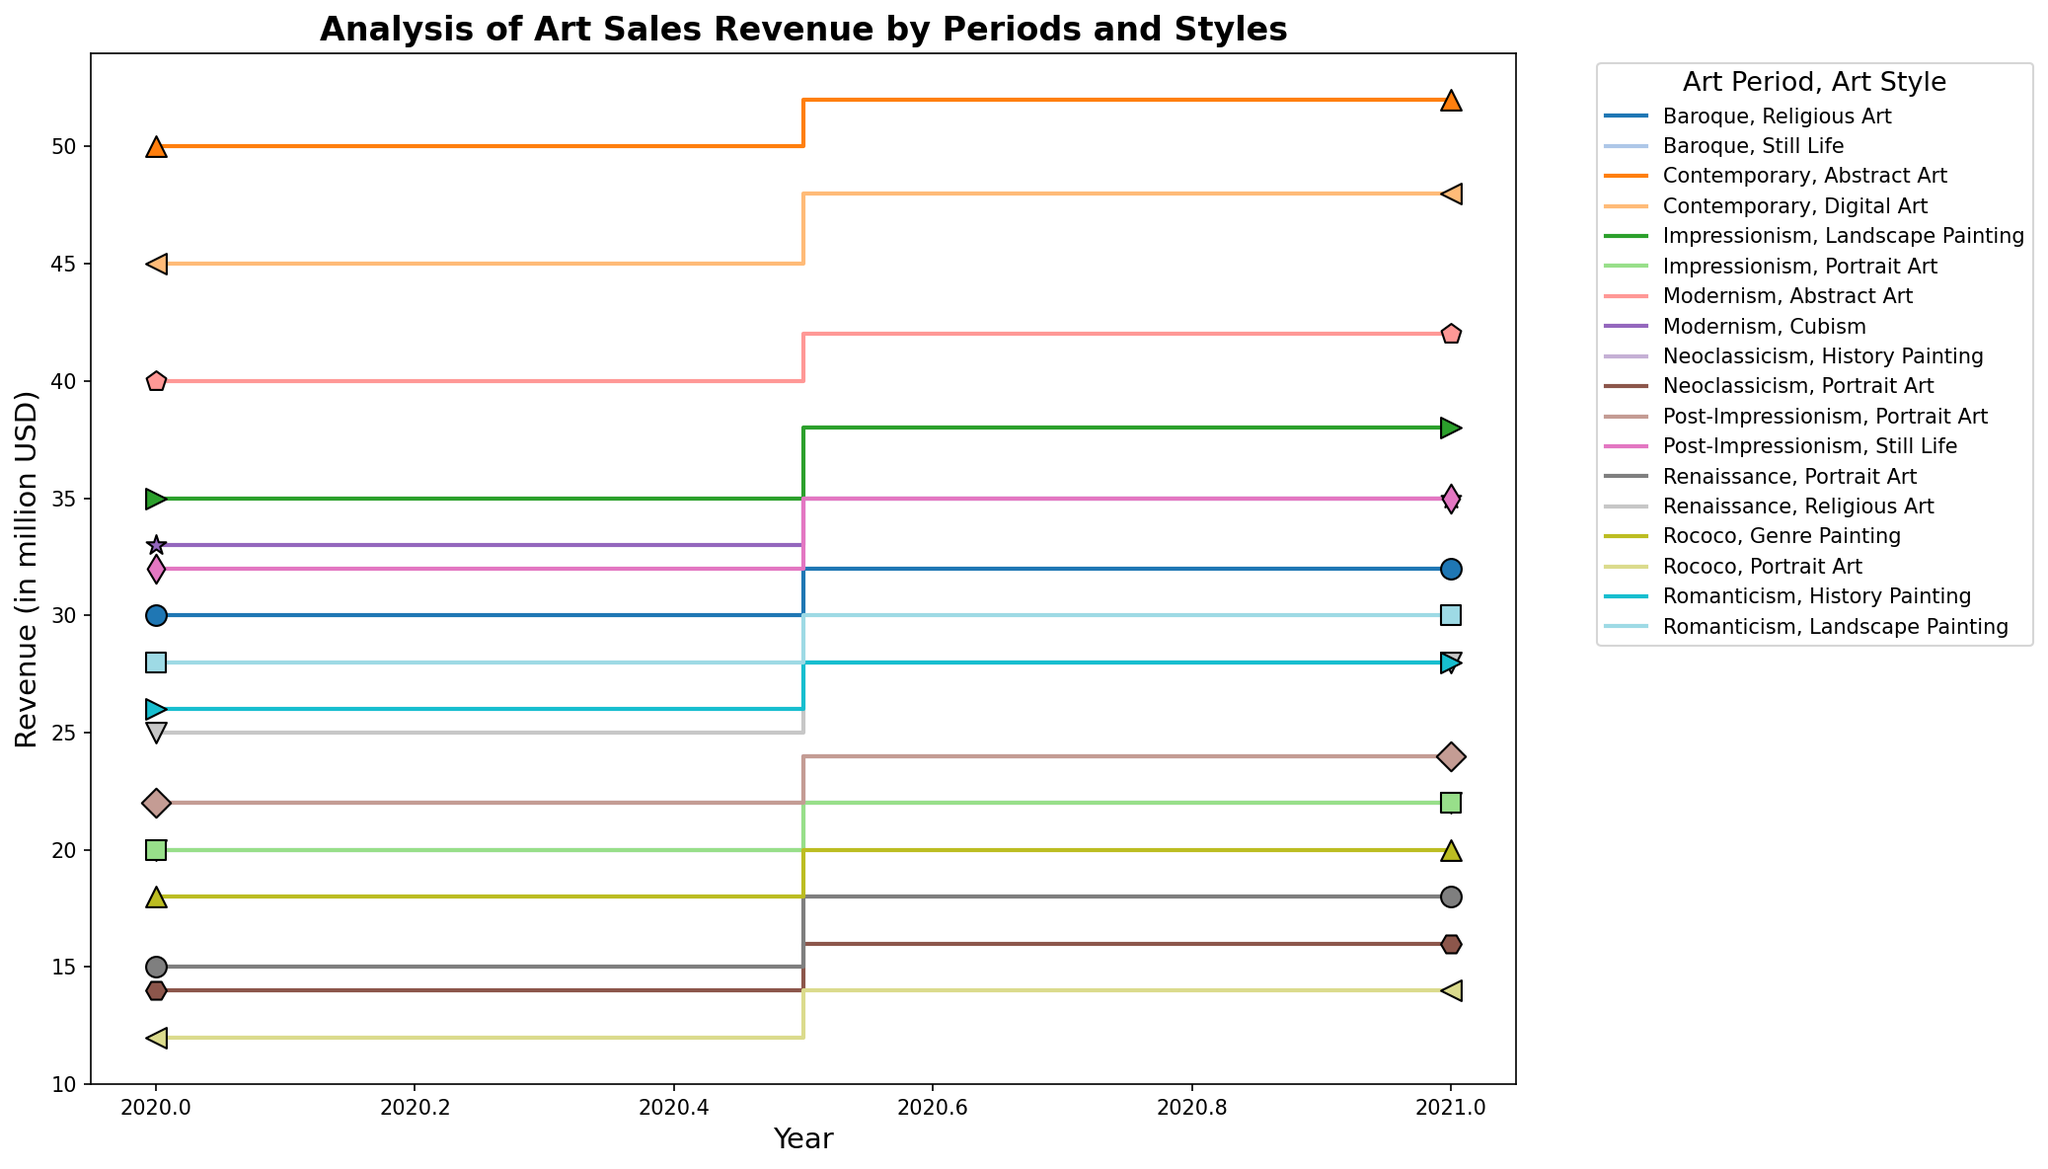In how many art periods did 'Abstract Art' generate revenue? 'Abstract Art' is only seen in the 'Modernism' and 'Contemporary' periods on the plot.
Answer: 2 Which art period and style had the highest revenue in 2021? Look for the tallest step in 2021, which corresponds to 'Contemporary, Abstract Art' with 52 million USD.
Answer: Contemporary, Abstract Art What is the total revenue generated by 'Portrait Art' across all periods in 2020? Sum the revenue of 'Portrait Art' in all periods for 2020: Renaissance (15) + Rococo (12) + Neoclassicism (14) + Impressionism (20) + Post-Impressionism (22) = 83 million USD.
Answer: 83 million USD Compare the revenue of 'Religious Art' between the Renaissance and Baroque periods in 2020. 'Religious Art' revenue in Renaissance (2020) is 25 million USD and in Baroque (2020) is 30 million USD. Baroque > Renaissance.
Answer: Baroque > Renaissance By how much did the revenue of 'Digital Art' increase from 2020 to 2021? Subtract the 2020 revenue (45 million USD) from the 2021 revenue (48 million USD) for 'Digital Art'. Difference = 48 - 45 = 3 million USD.
Answer: 3 million USD Which year had higher art sales revenue for 'Still Life' in the Baroque period? Compare 'Still Life' revenue in the Baroque period between 2020 (20 million USD) and 2021 (22 million USD). 2021 > 2020.
Answer: 2021 Which art style had a consistent revenue increase from 2020 to 2021? Check for art styles that have a higher revenue in 2021 compared to 2020 in all periods. 'Portrait Art' seems consistent with increases visible in Renaissance, Rococo, Neoclassicism, Impressionism, Post-Impressionism.
Answer: Portrait Art 